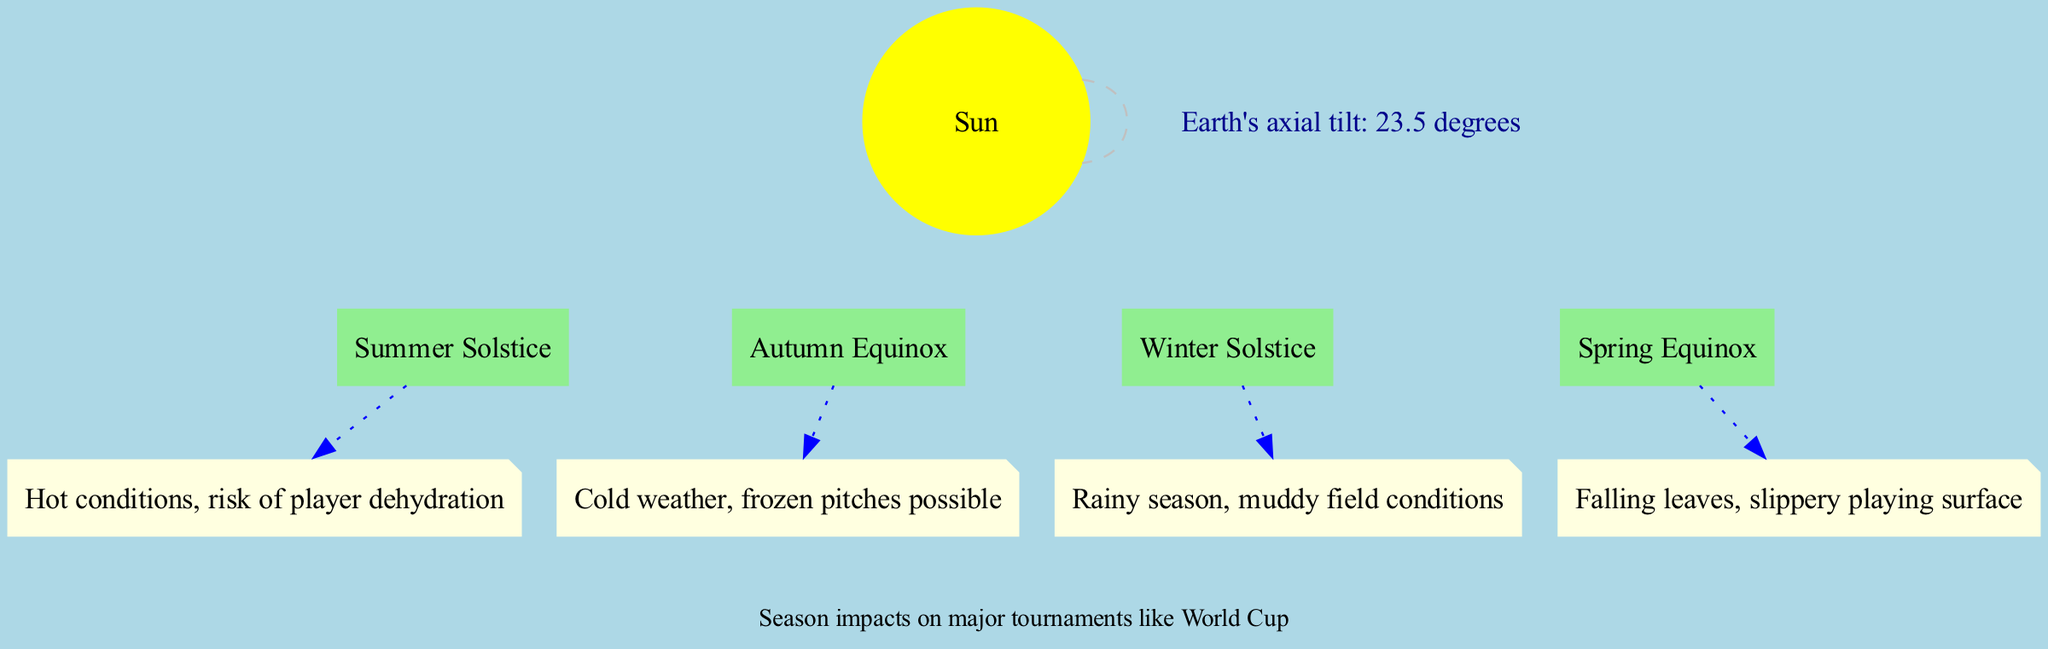What is the axial tilt of the Earth? The diagram shows a node with the axial tilt information, which directly indicates the measurement as 23.5 degrees.
Answer: 23.5 degrees What is the effect during Winter? By examining the seasonal effects mentioned in the diagram, the effect for Winter is described as "Cold weather, frozen pitches possible."
Answer: Cold weather, frozen pitches possible Which position corresponds to the longest day? The Summer Solstice is identified on the diagram as the position that represents the longest day, as stated in its description.
Answer: Summer Solstice How many key positions are there in the diagram? The diagram lists four distinct key positions: Summer Solstice, Autumn Equinox, Winter Solstice, and Spring Equinox, indicating a total of four positions.
Answer: Four What season has a risk of player dehydration? Looking at the seasonal effects described, the Summer season mentions "Hot conditions, risk of player dehydration," which directly answers the question.
Answer: Summer What effect is noted for the Autumn season? Within the seasonal effects on the diagram, Autumn is described with the effect of "Falling leaves, slippery playing surface."
Answer: Falling leaves, slippery playing surface Which equinox marks the start of many leagues? The Spring Equinox is specified in the diagram with the description "Moderate temperatures, start of many leagues," identifying it as the answer.
Answer: Spring Equinox How do rainy conditions affect soccer? The diagram notes that during the Spring season, the effect is "Rainy season, muddy field conditions," which can challenge playing soccer matches.
Answer: Rainy season, muddy field conditions 